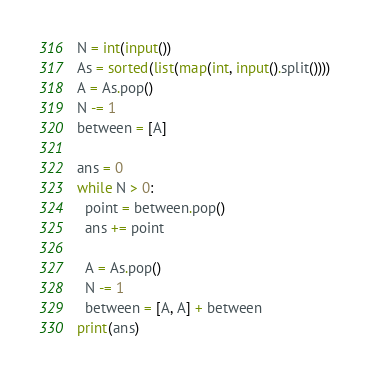<code> <loc_0><loc_0><loc_500><loc_500><_Python_>N = int(input())
As = sorted(list(map(int, input().split())))
A = As.pop()
N -= 1
between = [A]

ans = 0
while N > 0:
  point = between.pop()
  ans += point

  A = As.pop()
  N -= 1
  between = [A, A] + between
print(ans)</code> 